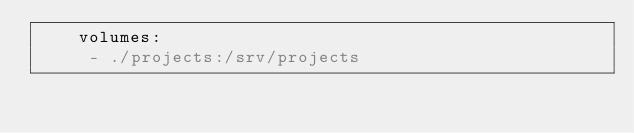<code> <loc_0><loc_0><loc_500><loc_500><_YAML_>    volumes:
     - ./projects:/srv/projects
</code> 